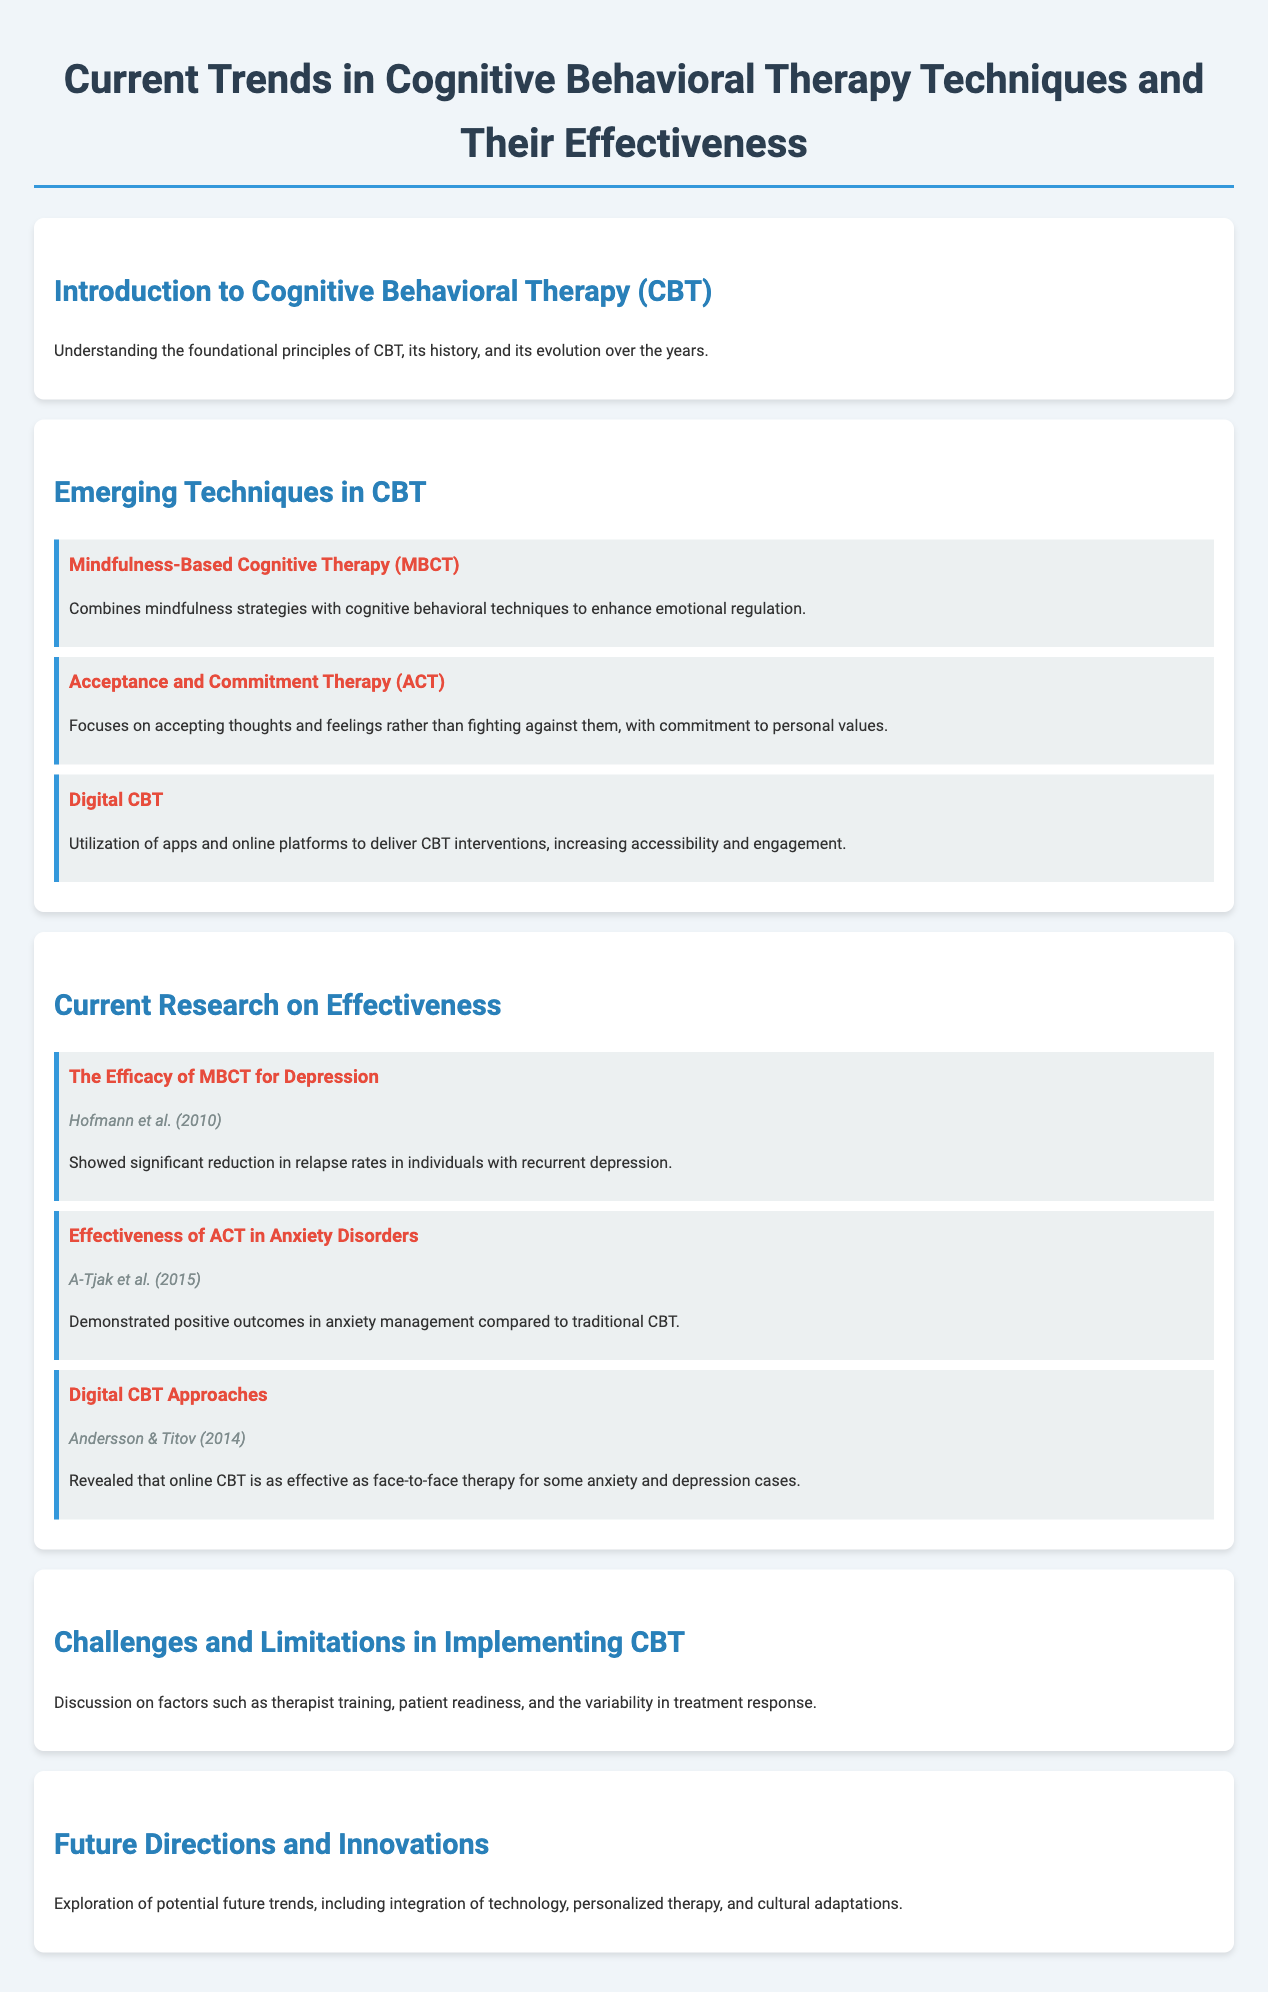What is the main focus of Mindfulness-Based Cognitive Therapy (MBCT)? MBCT combines mindfulness strategies with cognitive behavioral techniques to enhance emotional regulation.
Answer: emotional regulation Who authored the study on the efficacy of MBCT for depression? The source of the study on MBCT efficacy is Hofmann et al. from 2010.
Answer: Hofmann et al. (2010) What technique focuses on accepting thoughts and feelings? Acceptance and Commitment Therapy (ACT) emphasizes accepting thoughts and feelings rather than fighting against them.
Answer: Acceptance and Commitment Therapy (ACT) According to the document, how does Digital CBT improve accessibility? Digital CBT utilizes apps and online platforms to deliver CBT interventions.
Answer: apps and online platforms What was one outcome demonstrated in the study on ACT in anxiety disorders? The study by A-Tjak et al. (2015) showed positive outcomes in anxiety management compared to traditional CBT.
Answer: positive outcomes What is discussed as a limitation in implementing CBT? Factors such as therapist training, patient readiness, and the variability in treatment response are discussed as limitations.
Answer: therapist training, patient readiness, variability in treatment response What year was the study on Digital CBT approaches published? The study by Andersson & Titov about Digital CBT was published in 2014.
Answer: 2014 What is a potential future trend noted for CBT? Potential future trends include integration of technology, personalized therapy, and cultural adaptations.
Answer: integration of technology What does the introduction section cover regarding CBT? The introduction discusses the foundational principles of CBT, its history, and its evolution over the years.
Answer: foundational principles, history, evolution 